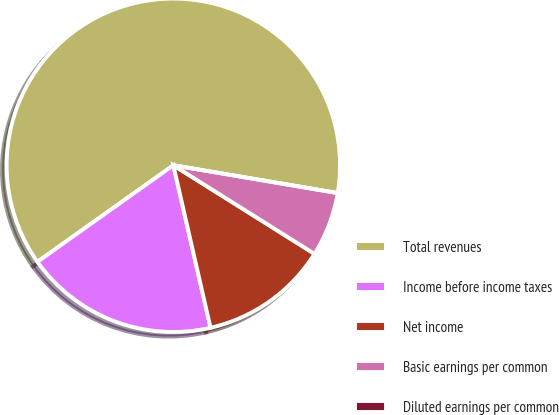Convert chart. <chart><loc_0><loc_0><loc_500><loc_500><pie_chart><fcel>Total revenues<fcel>Income before income taxes<fcel>Net income<fcel>Basic earnings per common<fcel>Diluted earnings per common<nl><fcel>62.5%<fcel>18.75%<fcel>12.5%<fcel>6.25%<fcel>0.0%<nl></chart> 